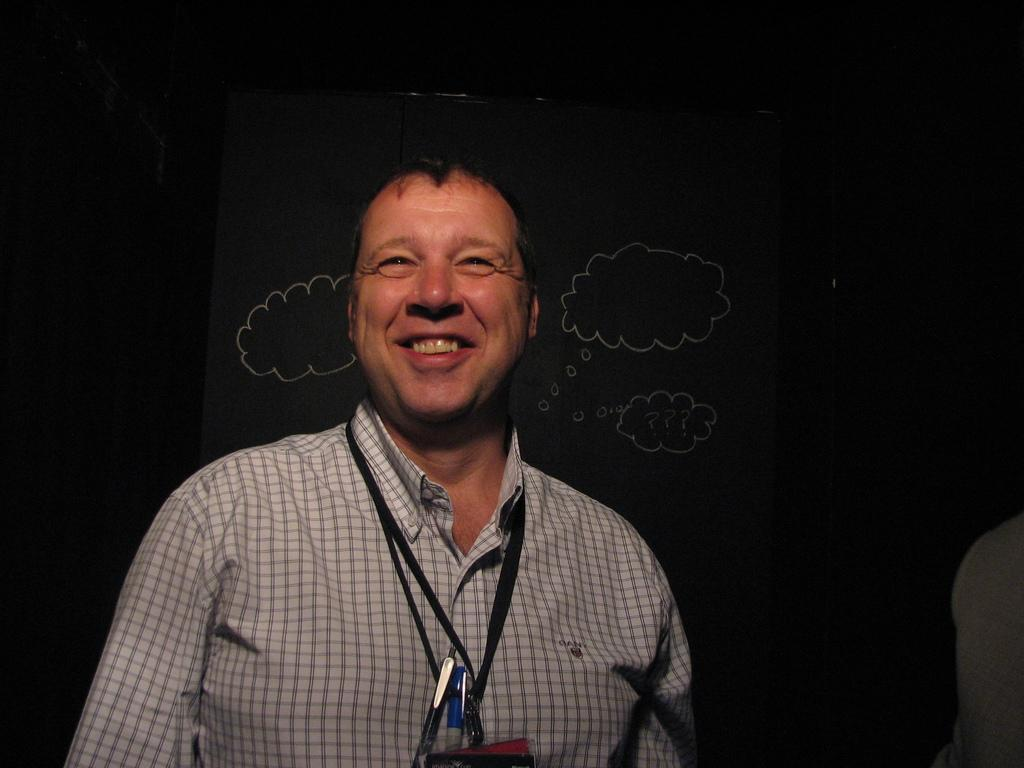Who is present in the image? There is a man in the image. What is the man wearing? The man is wearing a shirt in white color. What can be seen in the background of the image? There is a wall in the background of the image. What is the color of the wall? The wall is in black color. What is on the wall? There are drawings on the wall. What type of hat is the man wearing in the image? The man is not wearing a hat in the image; he is wearing a shirt in white color. What kind of experience can be gained from visiting the library in the image? There is no library present in the image, so it is not possible to gain any experience from visiting it. 